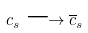<formula> <loc_0><loc_0><loc_500><loc_500>c _ { s } \longrightarrow \overline { c } _ { s }</formula> 